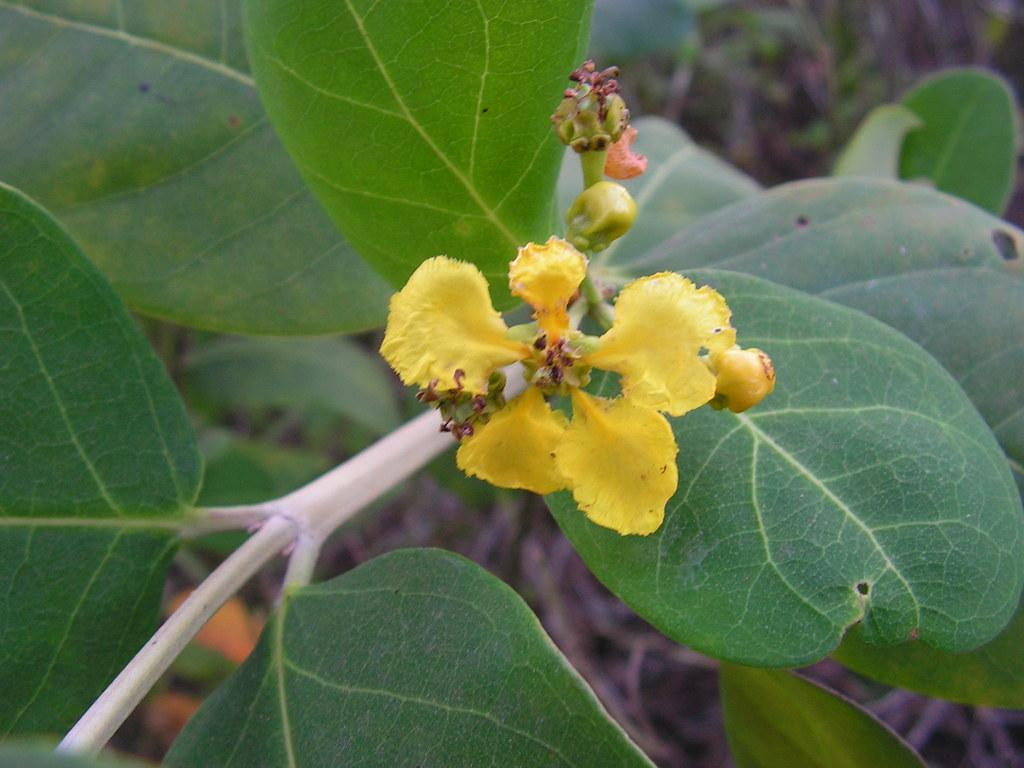What is the main subject in the center of the image? There is a flower in the center of the image. Can you describe the flower's surroundings? The flower is part of a plant. What type of match can be seen being used to light the flower in the image? There is no match present in the image, and the flower is not being lit. What color is the sock that is paired with the flower in the image? There is no sock present in the image; it only features a flower and a plant. 